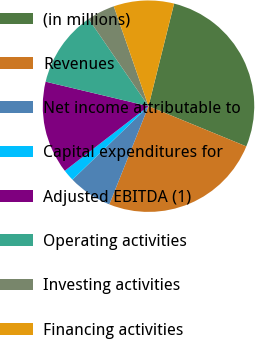Convert chart to OTSL. <chart><loc_0><loc_0><loc_500><loc_500><pie_chart><fcel>(in millions)<fcel>Revenues<fcel>Net income attributable to<fcel>Capital expenditures for<fcel>Adjusted EBITDA (1)<fcel>Operating activities<fcel>Investing activities<fcel>Financing activities<nl><fcel>27.32%<fcel>24.83%<fcel>6.73%<fcel>1.77%<fcel>14.18%<fcel>11.7%<fcel>4.25%<fcel>9.22%<nl></chart> 